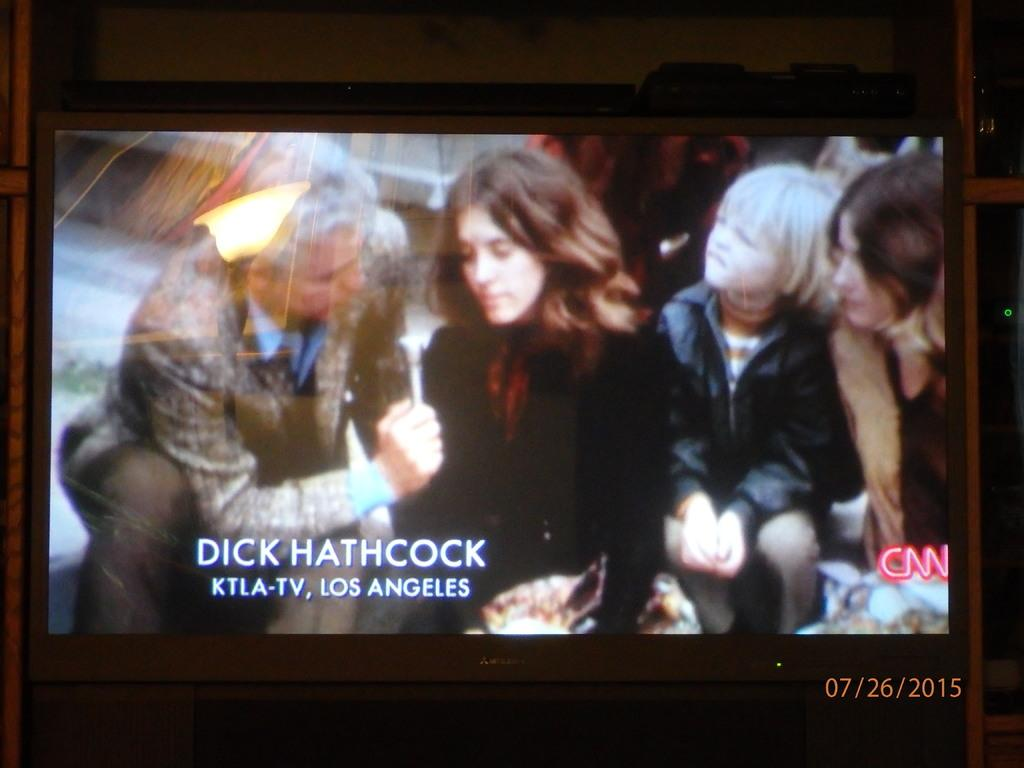<image>
Provide a brief description of the given image. A tv screen showing a news report and Dick Hathcock from KTLA. 